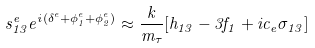<formula> <loc_0><loc_0><loc_500><loc_500>s _ { 1 3 } ^ { e } e ^ { i ( \delta ^ { e } + \phi ^ { e } _ { 1 } + \phi ^ { e } _ { 2 } ) } \approx \frac { k } { m _ { \tau } } [ h _ { 1 3 } - 3 f _ { 1 } + i c _ { e } \sigma _ { 1 3 } ]</formula> 